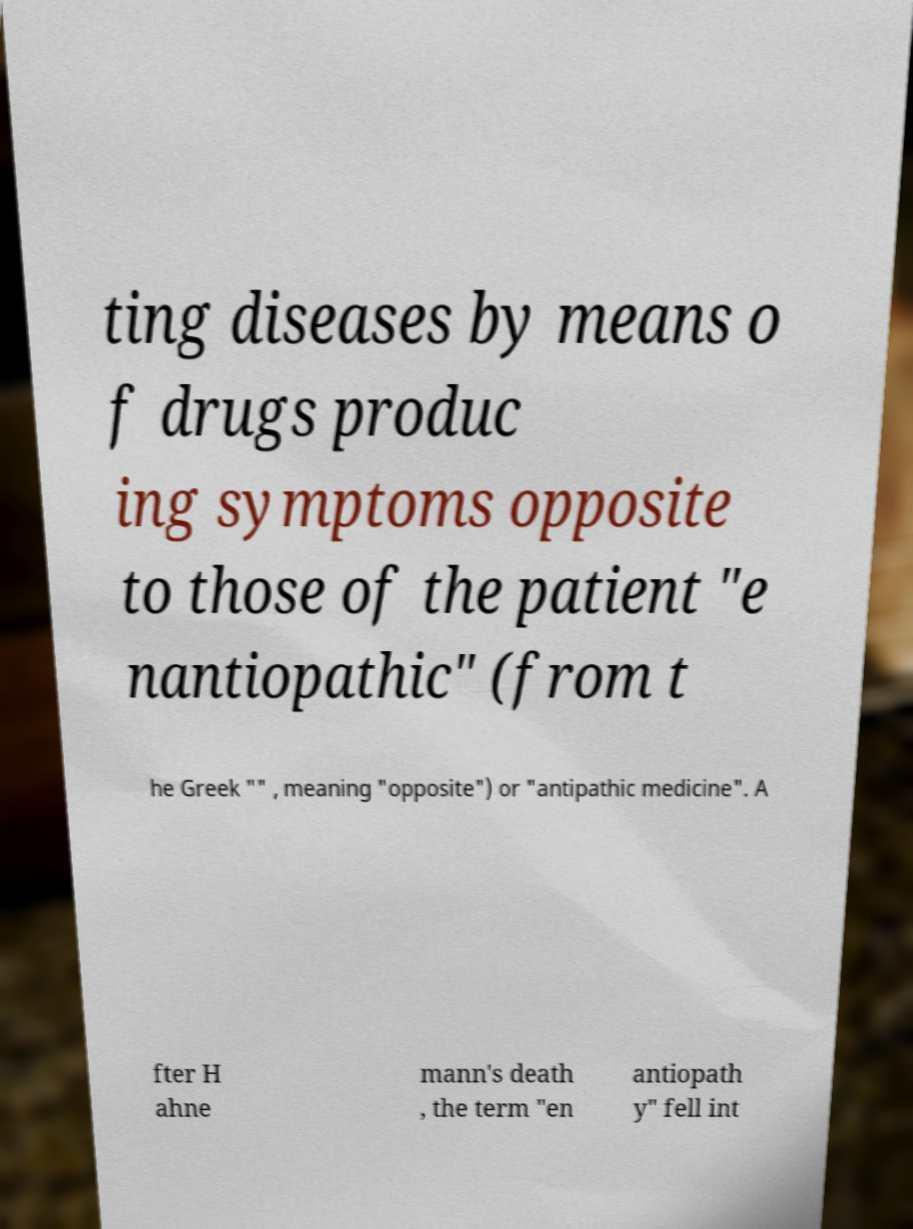Could you assist in decoding the text presented in this image and type it out clearly? ting diseases by means o f drugs produc ing symptoms opposite to those of the patient "e nantiopathic" (from t he Greek "" , meaning "opposite") or "antipathic medicine". A fter H ahne mann's death , the term "en antiopath y" fell int 